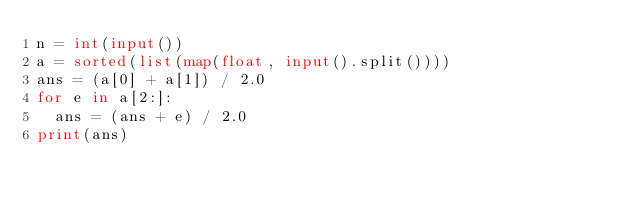Convert code to text. <code><loc_0><loc_0><loc_500><loc_500><_Python_>n = int(input())
a = sorted(list(map(float, input().split())))
ans = (a[0] + a[1]) / 2.0
for e in a[2:]:
  ans = (ans + e) / 2.0
print(ans)</code> 